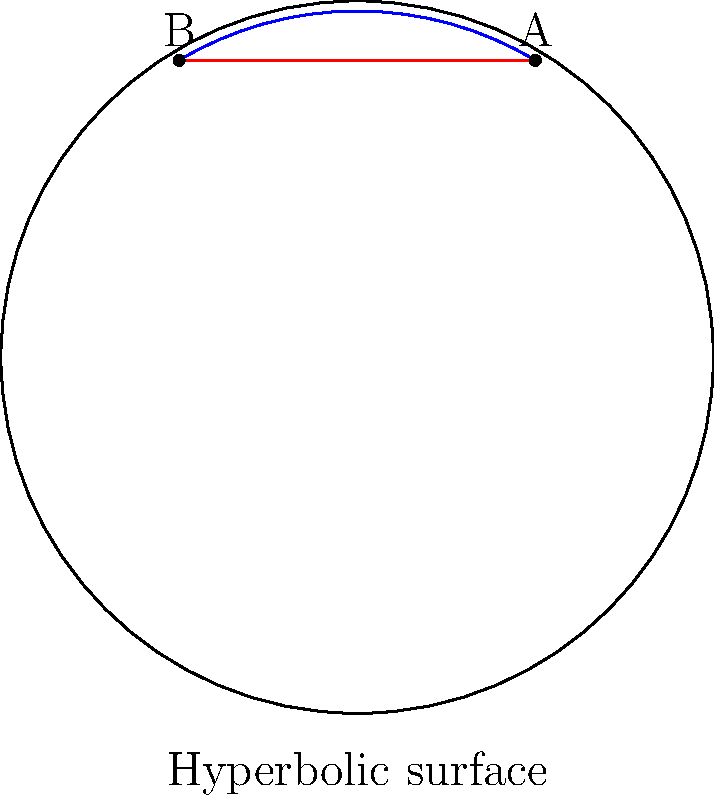At the prestigious Golden Globe Awards, you notice an intriguingly designed hyperbolic award statue. If points A and B represent two locations on the statue's surface, which path between these points would be shorter: the straight line (shown in red) or the curved arc (shown in blue)? To understand this problem, we need to consider the principles of non-Euclidean geometry, specifically hyperbolic geometry:

1. In hyperbolic geometry, the shortest path between two points is called a geodesic.

2. On a hyperbolic surface, geodesics are curved lines, not straight lines as in Euclidean geometry.

3. The blue arc in the diagram represents a geodesic on the hyperbolic surface of the award statue.

4. The red line represents what would appear to be a straight line in Euclidean space, but on a hyperbolic surface, this is not the shortest path.

5. In hyperbolic geometry, parallel lines diverge, and the sum of angles in a triangle is less than 180 degrees. These properties cause straight lines to bend on a hyperbolic surface.

6. The curved geodesic (blue arc) follows the curvature of the hyperbolic surface, making it the shortest path between points A and B on the statue.

Therefore, despite appearances, the curved blue arc is actually the shorter path between points A and B on the hyperbolic surface of the award statue.
Answer: The curved arc (blue) 